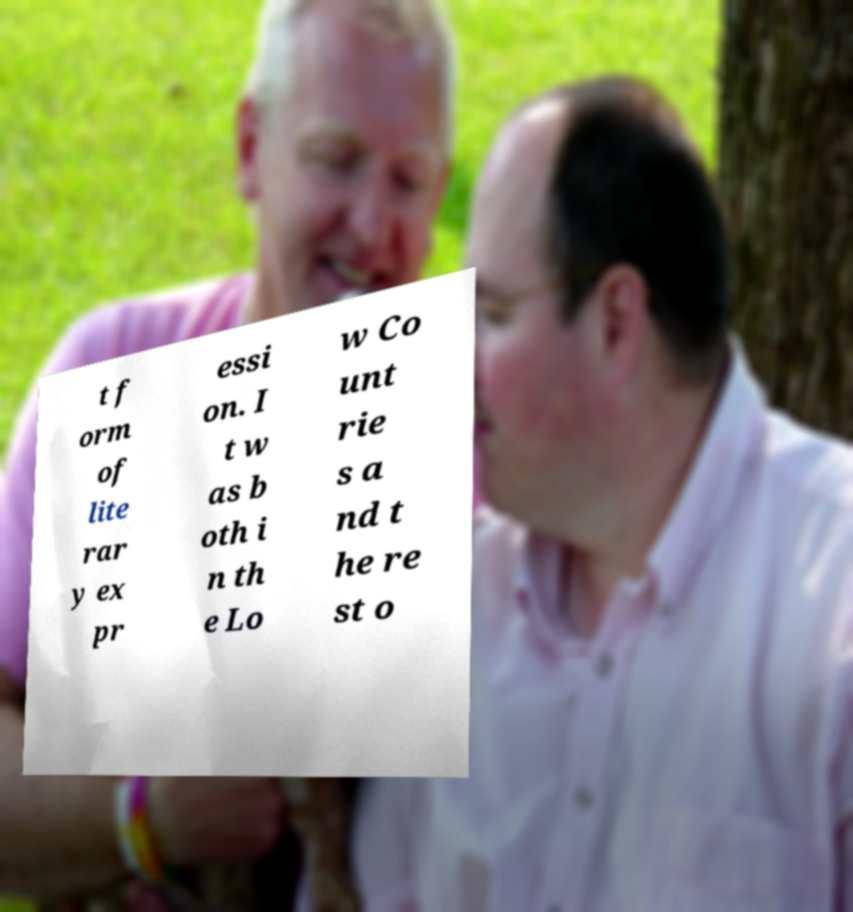Could you assist in decoding the text presented in this image and type it out clearly? t f orm of lite rar y ex pr essi on. I t w as b oth i n th e Lo w Co unt rie s a nd t he re st o 